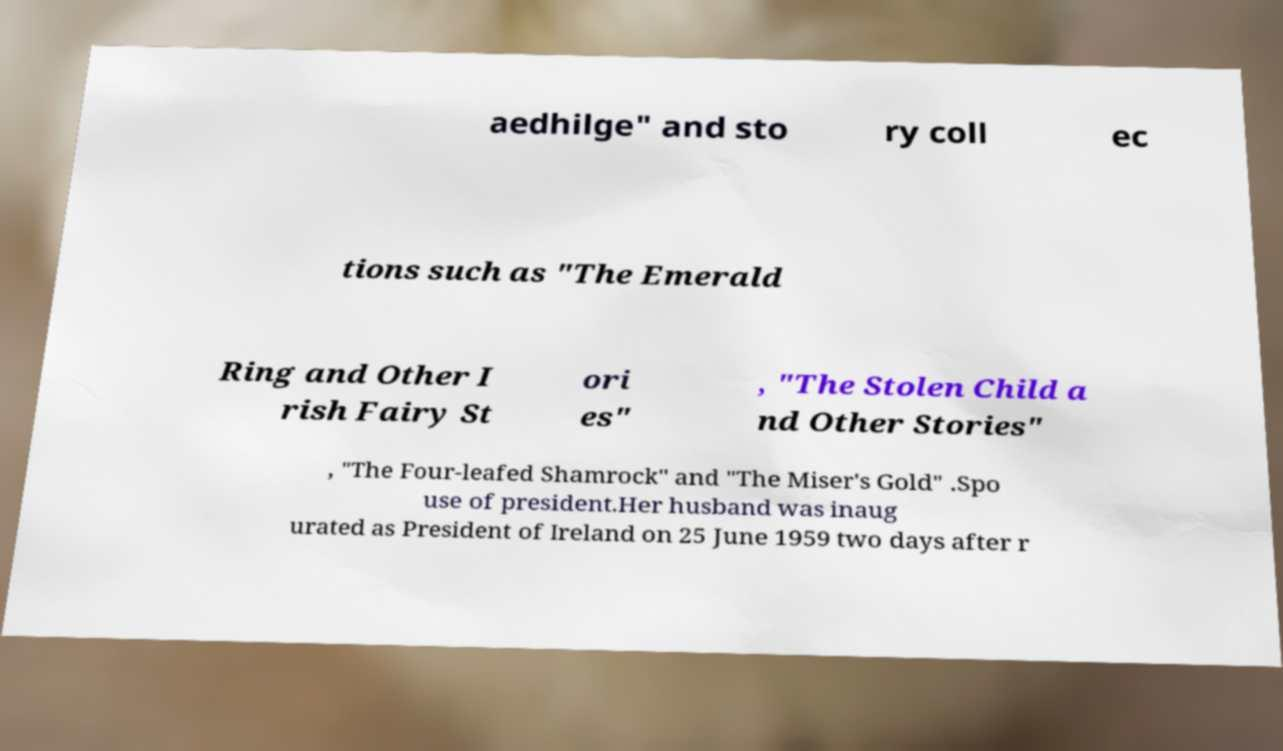For documentation purposes, I need the text within this image transcribed. Could you provide that? aedhilge" and sto ry coll ec tions such as "The Emerald Ring and Other I rish Fairy St ori es" , "The Stolen Child a nd Other Stories" , "The Four-leafed Shamrock" and "The Miser's Gold" .Spo use of president.Her husband was inaug urated as President of Ireland on 25 June 1959 two days after r 